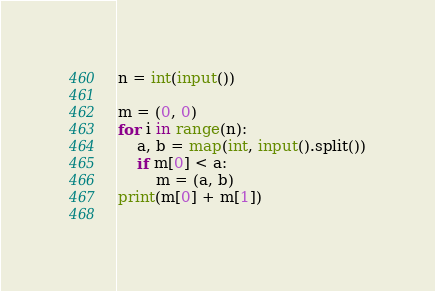<code> <loc_0><loc_0><loc_500><loc_500><_Python_>n = int(input())

m = (0, 0)
for i in range(n):
    a, b = map(int, input().split())
    if m[0] < a:
        m = (a, b)
print(m[0] + m[1])
    

</code> 